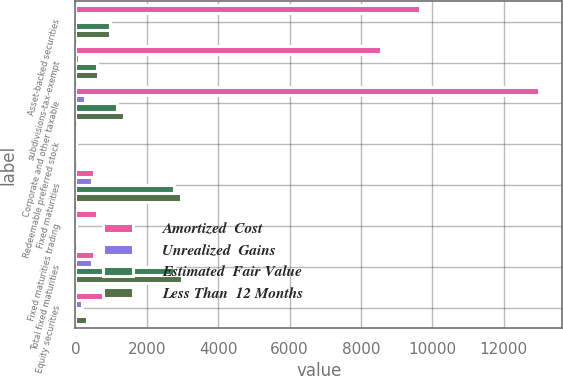Convert chart to OTSL. <chart><loc_0><loc_0><loc_500><loc_500><stacked_bar_chart><ecel><fcel>Asset-backed securities<fcel>subdivisions-tax-exempt<fcel>Corporate and other taxable<fcel>Redeemable preferred stock<fcel>Fixed maturities<fcel>Fixed maturities trading<fcel>Total fixed maturities<fcel>Equity securities<nl><fcel>Amortized  Cost<fcel>9670<fcel>8557<fcel>12993<fcel>72<fcel>534.5<fcel>613<fcel>534.5<fcel>1018<nl><fcel>Unrealized  Gains<fcel>24<fcel>90<fcel>275<fcel>1<fcel>459<fcel>1<fcel>460<fcel>195<nl><fcel>Estimated  Fair Value<fcel>961<fcel>609<fcel>1164<fcel>23<fcel>2758<fcel>19<fcel>2777<fcel>16<nl><fcel>Less Than  12 Months<fcel>969<fcel>623<fcel>1374<fcel>3<fcel>2969<fcel>30<fcel>2999<fcel>324<nl></chart> 